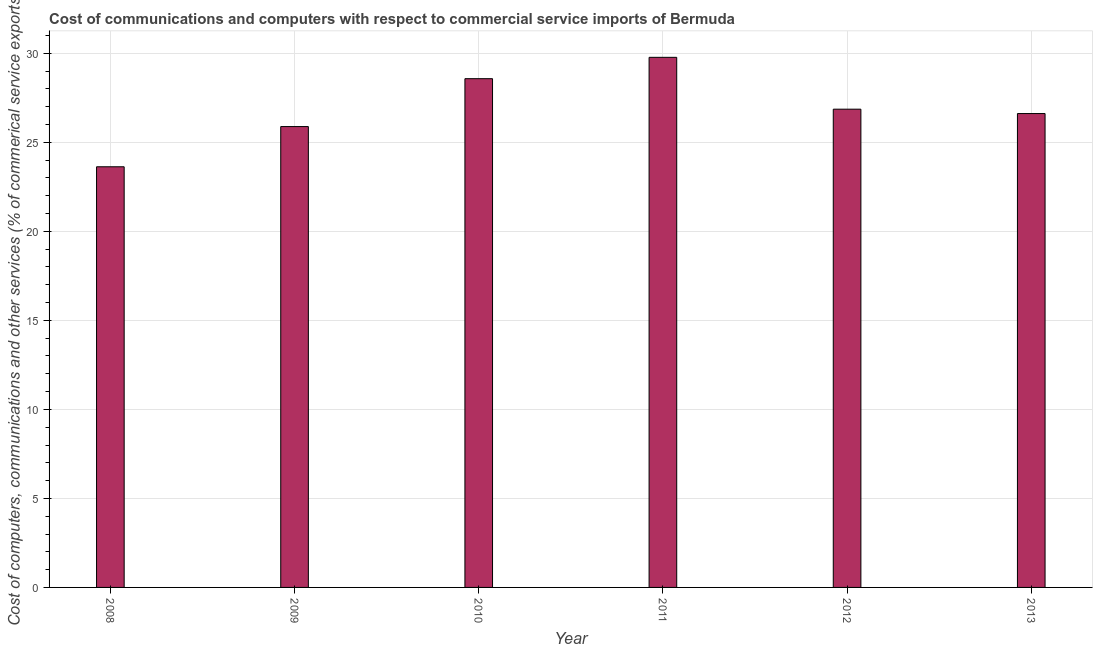Does the graph contain any zero values?
Give a very brief answer. No. What is the title of the graph?
Make the answer very short. Cost of communications and computers with respect to commercial service imports of Bermuda. What is the label or title of the Y-axis?
Offer a terse response. Cost of computers, communications and other services (% of commerical service exports). What is the cost of communications in 2009?
Your answer should be compact. 25.89. Across all years, what is the maximum  computer and other services?
Keep it short and to the point. 29.78. Across all years, what is the minimum cost of communications?
Provide a short and direct response. 23.63. In which year was the  computer and other services maximum?
Offer a terse response. 2011. In which year was the  computer and other services minimum?
Provide a succinct answer. 2008. What is the sum of the  computer and other services?
Offer a terse response. 161.35. What is the difference between the  computer and other services in 2010 and 2013?
Keep it short and to the point. 1.96. What is the average  computer and other services per year?
Your response must be concise. 26.89. What is the median  computer and other services?
Offer a very short reply. 26.74. What is the ratio of the cost of communications in 2008 to that in 2010?
Your answer should be very brief. 0.83. What is the difference between the highest and the second highest  computer and other services?
Provide a short and direct response. 1.2. What is the difference between the highest and the lowest cost of communications?
Your answer should be very brief. 6.15. In how many years, is the cost of communications greater than the average cost of communications taken over all years?
Ensure brevity in your answer.  2. What is the difference between two consecutive major ticks on the Y-axis?
Your answer should be compact. 5. What is the Cost of computers, communications and other services (% of commerical service exports) of 2008?
Make the answer very short. 23.63. What is the Cost of computers, communications and other services (% of commerical service exports) of 2009?
Give a very brief answer. 25.89. What is the Cost of computers, communications and other services (% of commerical service exports) in 2010?
Provide a succinct answer. 28.58. What is the Cost of computers, communications and other services (% of commerical service exports) in 2011?
Your response must be concise. 29.78. What is the Cost of computers, communications and other services (% of commerical service exports) in 2012?
Offer a terse response. 26.86. What is the Cost of computers, communications and other services (% of commerical service exports) in 2013?
Make the answer very short. 26.62. What is the difference between the Cost of computers, communications and other services (% of commerical service exports) in 2008 and 2009?
Your response must be concise. -2.26. What is the difference between the Cost of computers, communications and other services (% of commerical service exports) in 2008 and 2010?
Offer a terse response. -4.95. What is the difference between the Cost of computers, communications and other services (% of commerical service exports) in 2008 and 2011?
Keep it short and to the point. -6.15. What is the difference between the Cost of computers, communications and other services (% of commerical service exports) in 2008 and 2012?
Your answer should be compact. -3.24. What is the difference between the Cost of computers, communications and other services (% of commerical service exports) in 2008 and 2013?
Offer a very short reply. -2.99. What is the difference between the Cost of computers, communications and other services (% of commerical service exports) in 2009 and 2010?
Make the answer very short. -2.69. What is the difference between the Cost of computers, communications and other services (% of commerical service exports) in 2009 and 2011?
Offer a very short reply. -3.89. What is the difference between the Cost of computers, communications and other services (% of commerical service exports) in 2009 and 2012?
Provide a succinct answer. -0.98. What is the difference between the Cost of computers, communications and other services (% of commerical service exports) in 2009 and 2013?
Offer a very short reply. -0.73. What is the difference between the Cost of computers, communications and other services (% of commerical service exports) in 2010 and 2011?
Your answer should be very brief. -1.2. What is the difference between the Cost of computers, communications and other services (% of commerical service exports) in 2010 and 2012?
Ensure brevity in your answer.  1.71. What is the difference between the Cost of computers, communications and other services (% of commerical service exports) in 2010 and 2013?
Provide a short and direct response. 1.96. What is the difference between the Cost of computers, communications and other services (% of commerical service exports) in 2011 and 2012?
Provide a short and direct response. 2.91. What is the difference between the Cost of computers, communications and other services (% of commerical service exports) in 2011 and 2013?
Make the answer very short. 3.16. What is the difference between the Cost of computers, communications and other services (% of commerical service exports) in 2012 and 2013?
Provide a short and direct response. 0.25. What is the ratio of the Cost of computers, communications and other services (% of commerical service exports) in 2008 to that in 2010?
Provide a short and direct response. 0.83. What is the ratio of the Cost of computers, communications and other services (% of commerical service exports) in 2008 to that in 2011?
Ensure brevity in your answer.  0.79. What is the ratio of the Cost of computers, communications and other services (% of commerical service exports) in 2008 to that in 2012?
Provide a short and direct response. 0.88. What is the ratio of the Cost of computers, communications and other services (% of commerical service exports) in 2008 to that in 2013?
Make the answer very short. 0.89. What is the ratio of the Cost of computers, communications and other services (% of commerical service exports) in 2009 to that in 2010?
Make the answer very short. 0.91. What is the ratio of the Cost of computers, communications and other services (% of commerical service exports) in 2009 to that in 2011?
Your answer should be very brief. 0.87. What is the ratio of the Cost of computers, communications and other services (% of commerical service exports) in 2009 to that in 2012?
Your response must be concise. 0.96. What is the ratio of the Cost of computers, communications and other services (% of commerical service exports) in 2010 to that in 2011?
Your answer should be very brief. 0.96. What is the ratio of the Cost of computers, communications and other services (% of commerical service exports) in 2010 to that in 2012?
Give a very brief answer. 1.06. What is the ratio of the Cost of computers, communications and other services (% of commerical service exports) in 2010 to that in 2013?
Your response must be concise. 1.07. What is the ratio of the Cost of computers, communications and other services (% of commerical service exports) in 2011 to that in 2012?
Keep it short and to the point. 1.11. What is the ratio of the Cost of computers, communications and other services (% of commerical service exports) in 2011 to that in 2013?
Ensure brevity in your answer.  1.12. 